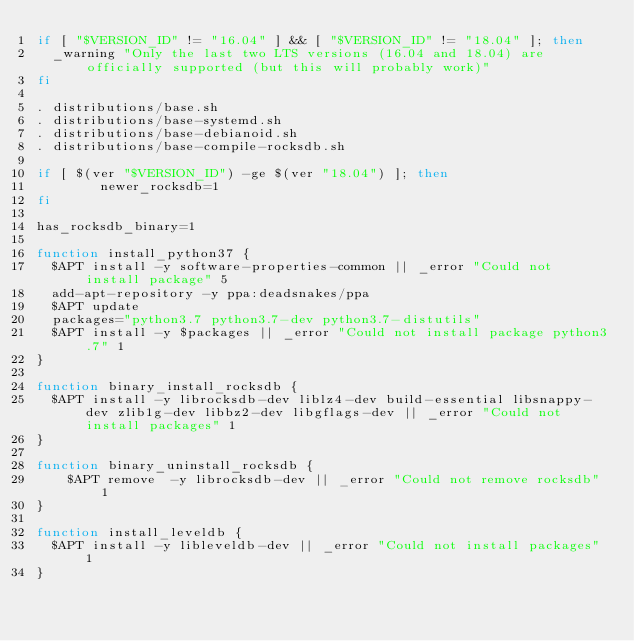Convert code to text. <code><loc_0><loc_0><loc_500><loc_500><_Bash_>if [ "$VERSION_ID" != "16.04" ] && [ "$VERSION_ID" != "18.04" ]; then
	_warning "Only the last two LTS versions (16.04 and 18.04) are officially supported (but this will probably work)"
fi

. distributions/base.sh
. distributions/base-systemd.sh
. distributions/base-debianoid.sh
. distributions/base-compile-rocksdb.sh

if [ $(ver "$VERSION_ID") -ge $(ver "18.04") ]; then
        newer_rocksdb=1
fi

has_rocksdb_binary=1

function install_python37 {
	$APT install -y software-properties-common || _error "Could not install package" 5
	add-apt-repository -y ppa:deadsnakes/ppa
	$APT update
	packages="python3.7 python3.7-dev python3.7-distutils"
	$APT install -y $packages || _error "Could not install package python3.7" 1
}

function binary_install_rocksdb {
	$APT install -y librocksdb-dev liblz4-dev build-essential libsnappy-dev zlib1g-dev libbz2-dev libgflags-dev || _error "Could not install packages" 1
}

function binary_uninstall_rocksdb {
    $APT remove  -y librocksdb-dev || _error "Could not remove rocksdb" 1
}

function install_leveldb {
	$APT install -y libleveldb-dev || _error "Could not install packages" 1
}
</code> 